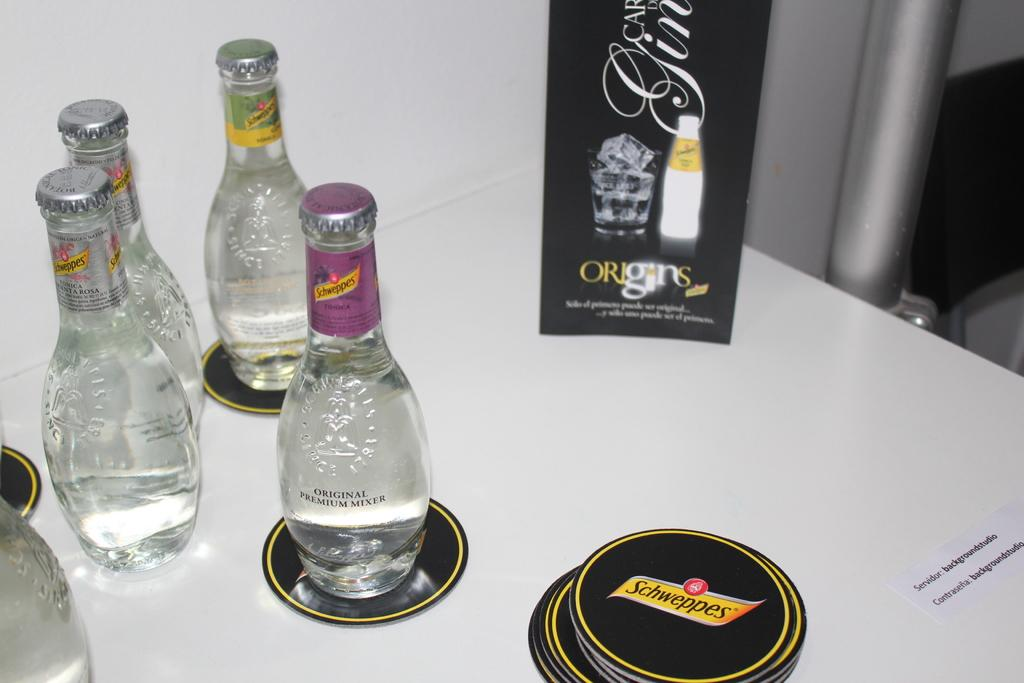What can be seen in the image that contains liquids? There are bottles with liquids in the image. What else is present in the image besides the bottles with liquids? There is a name origin with pictures in the image. Reasoning: Let's think step by breaking down the facts to create the conversation. We start by identifying the main subjects in the image, which are the bottles with liquids and the name origin with pictures. Then, we formulate questions that focus on these subjects, ensuring that each question can be answered definitively with the information given. We avoid yes/no questions and ensure that the language is simple and clear. Absurd Question/Answer: What type of metal can be seen being used in a protest in the image? There is no protest or metal present in the image; it only contains bottles with liquids and a name origin with pictures. 